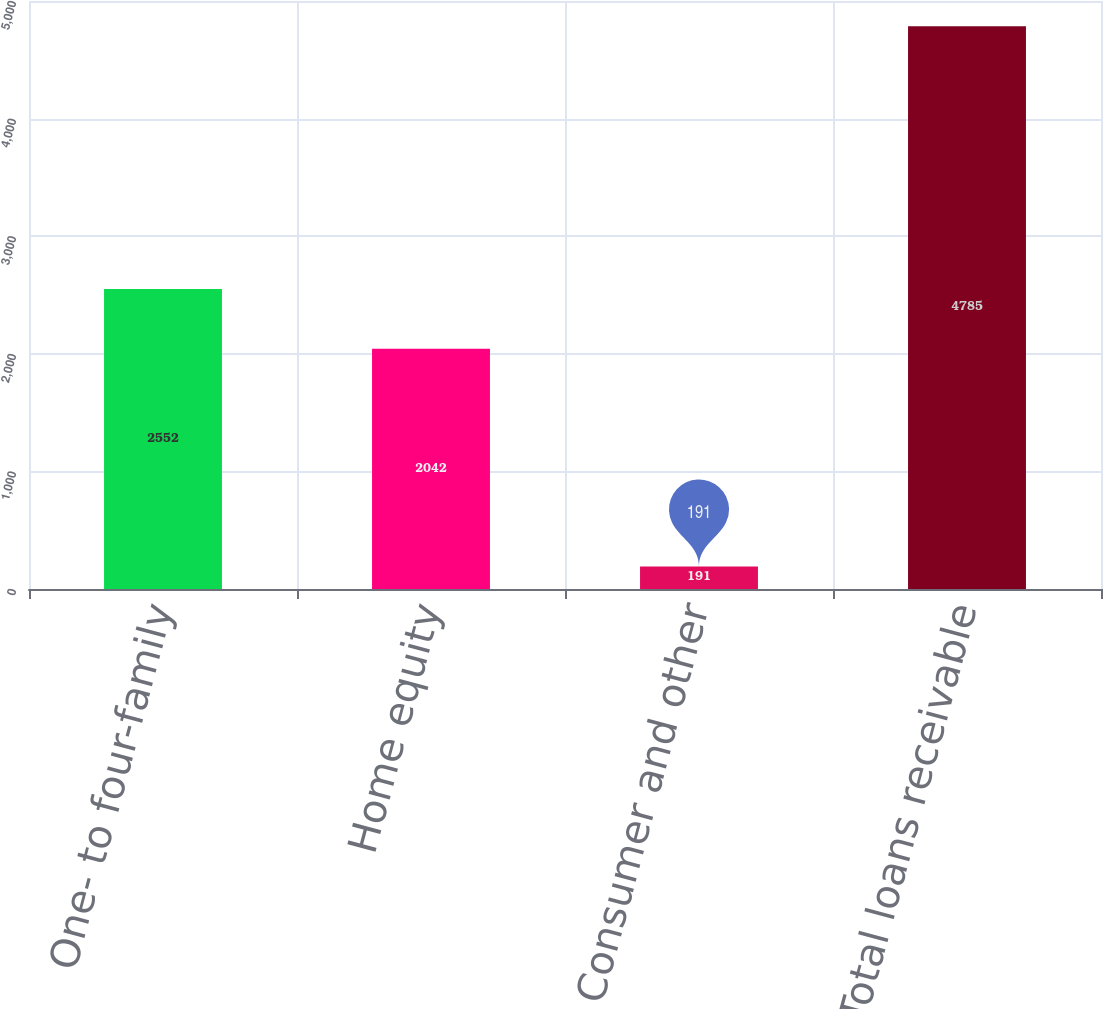<chart> <loc_0><loc_0><loc_500><loc_500><bar_chart><fcel>One- to four-family<fcel>Home equity<fcel>Consumer and other<fcel>Total loans receivable<nl><fcel>2552<fcel>2042<fcel>191<fcel>4785<nl></chart> 